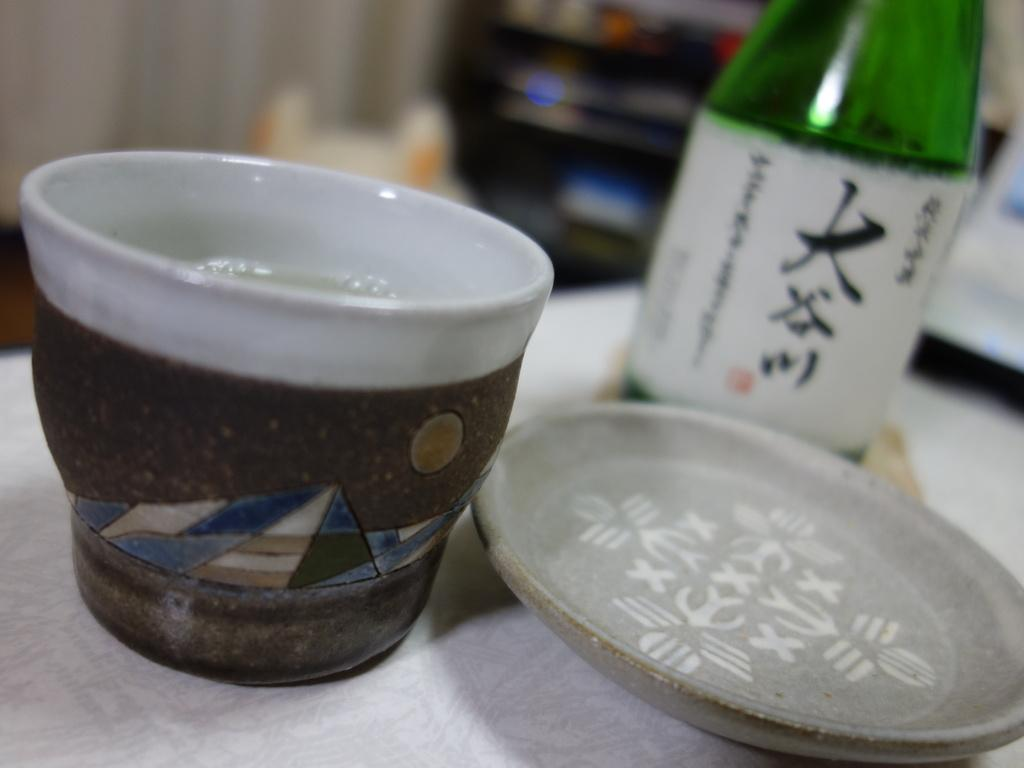What is present in the image that can hold a liquid? There is a cup in the image that can hold a liquid. What is another object in the image that is often used with a cup? There is a saucer in the image, which is often used with a cup. What type of beverage might be associated with the wine bottle in the image? The wine bottle in the image might contain wine, a type of alcoholic beverage. What can be seen in the background of the image? The background of the image includes a curtain. What surface is visible beneath the objects in the image? There is a floor visible in the image. Where is the lunchroom located in the image? There is no mention of a lunchroom in the image or the provided facts. --- Facts: 1. There is a person holding a book in the image. 2. The person is sitting on a chair. 3. There is a table in the image. 4. The table has a lamp on it. 5. The background of the image includes a bookshelf. Absurd Topics: parrot, ocean, volcano Conversation: What is the person in the image holding? The person in the image is holding a book. What is the person sitting on in the image? The person is sitting on a chair. What object is present in the image that might provide light? There is a lamp on the table in the image. What can be seen in the background of the image? The background of the image includes a bookshelf. What surface is visible beneath the person in the image? The table is visible beneath the person in the image. Reasoning: Let's think step by step in order to produce the conversation. We start by identifying the main subject in the image, which is the person holding a book. Then, we expand the conversation to include other details about the image, such as the chair, table, lamp, and bookshelf. Each question is designed to elicit a specific detail about the image that is known from the provided facts. Absurd Question/Answer: Can you see any parrots flying over the ocean in the image? There is no mention of parrots, oceans, or volcanoes in the image or the provided facts. 